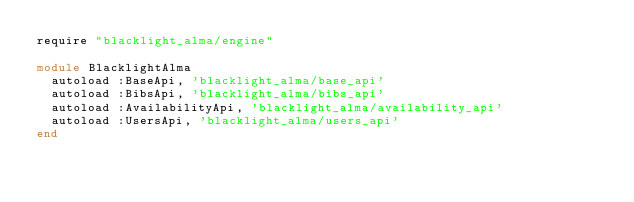<code> <loc_0><loc_0><loc_500><loc_500><_Ruby_>require "blacklight_alma/engine"

module BlacklightAlma
  autoload :BaseApi, 'blacklight_alma/base_api'
  autoload :BibsApi, 'blacklight_alma/bibs_api'
  autoload :AvailabilityApi, 'blacklight_alma/availability_api'
  autoload :UsersApi, 'blacklight_alma/users_api'
end
</code> 